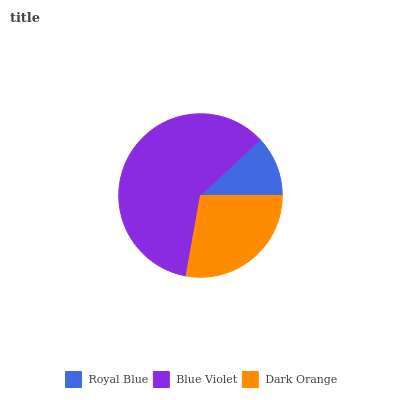Is Royal Blue the minimum?
Answer yes or no. Yes. Is Blue Violet the maximum?
Answer yes or no. Yes. Is Dark Orange the minimum?
Answer yes or no. No. Is Dark Orange the maximum?
Answer yes or no. No. Is Blue Violet greater than Dark Orange?
Answer yes or no. Yes. Is Dark Orange less than Blue Violet?
Answer yes or no. Yes. Is Dark Orange greater than Blue Violet?
Answer yes or no. No. Is Blue Violet less than Dark Orange?
Answer yes or no. No. Is Dark Orange the high median?
Answer yes or no. Yes. Is Dark Orange the low median?
Answer yes or no. Yes. Is Blue Violet the high median?
Answer yes or no. No. Is Royal Blue the low median?
Answer yes or no. No. 